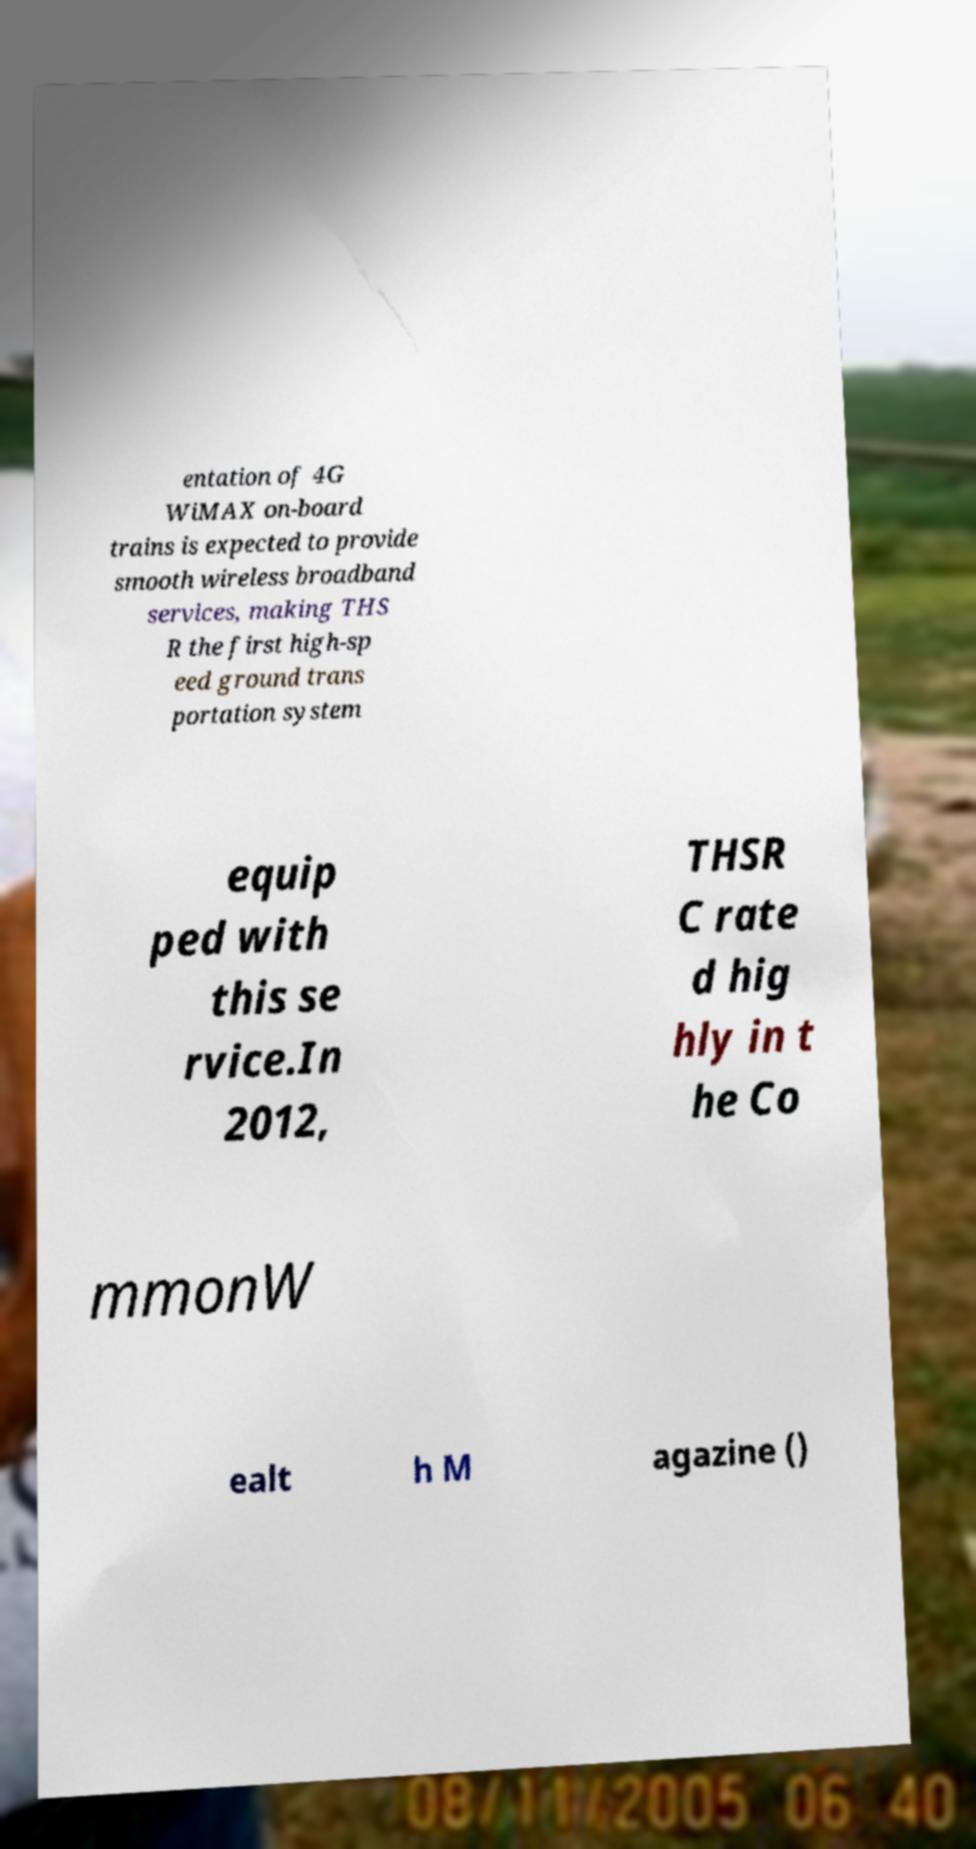Could you assist in decoding the text presented in this image and type it out clearly? entation of 4G WiMAX on-board trains is expected to provide smooth wireless broadband services, making THS R the first high-sp eed ground trans portation system equip ped with this se rvice.In 2012, THSR C rate d hig hly in t he Co mmonW ealt h M agazine () 